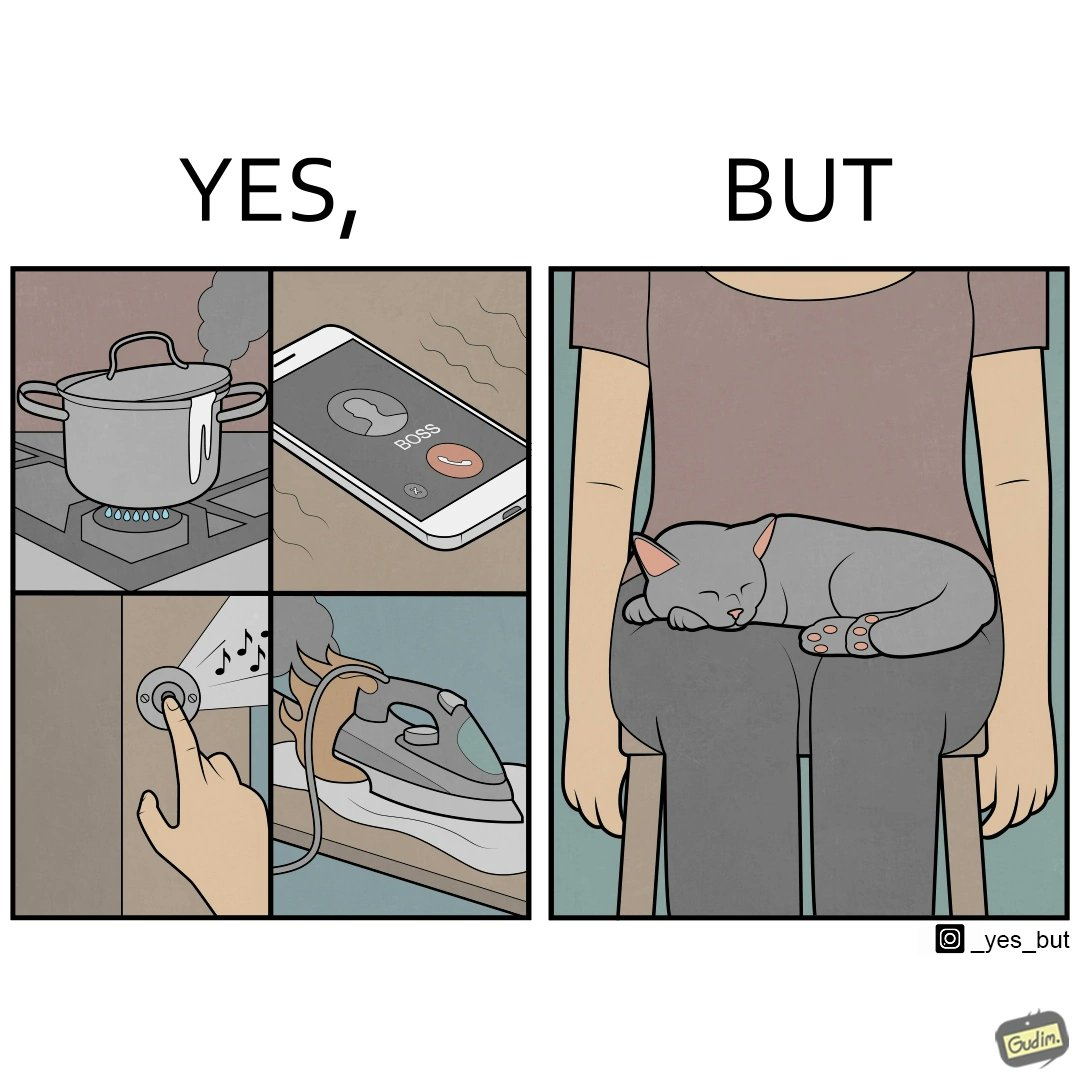Compare the left and right sides of this image. In the left part of the image: Image depicts chaos in a household with overflowing pots, ringing phone, door bell going off, and the iron burning clothes In the right part of the image: a cat sleeping on the lap of a person 